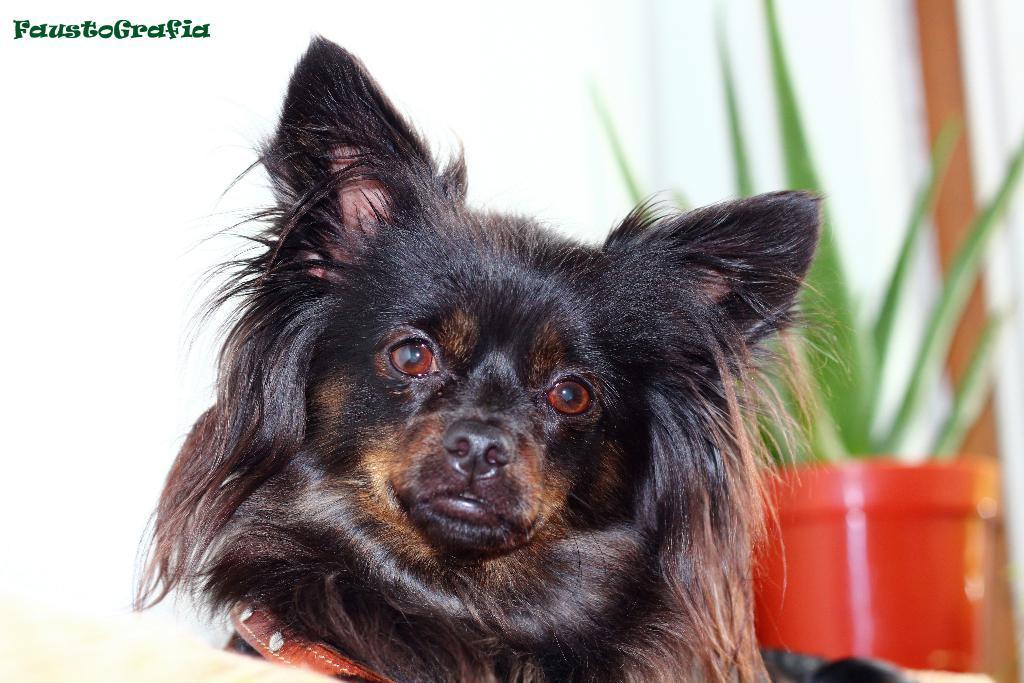Could you give a brief overview of what you see in this image? In this picture I can see a dog. In the background I can see a plant pot. Here I can see a watermark. 